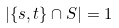<formula> <loc_0><loc_0><loc_500><loc_500>| \{ s , t \} \cap S | = 1</formula> 